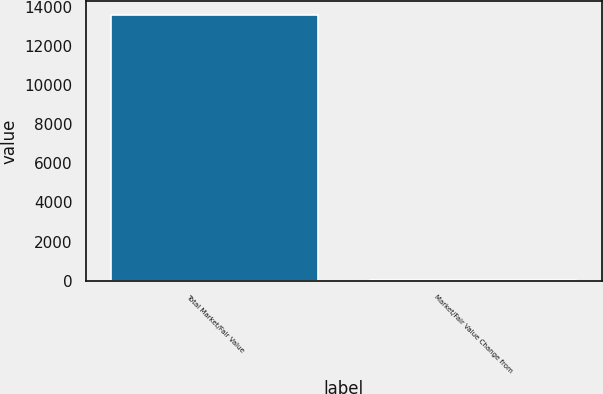<chart> <loc_0><loc_0><loc_500><loc_500><bar_chart><fcel>Total Market/Fair Value<fcel>Market/Fair Value Change from<nl><fcel>13616.7<fcel>6.3<nl></chart> 